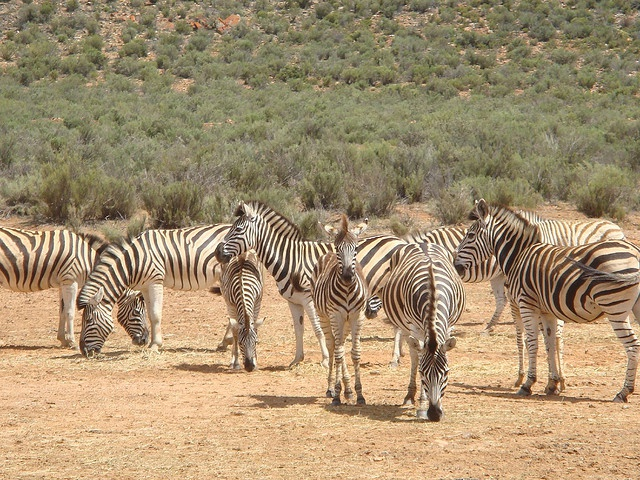Describe the objects in this image and their specific colors. I can see zebra in darkgreen, gray, tan, black, and maroon tones, zebra in darkgreen, beige, tan, and gray tones, zebra in darkgreen, gray, tan, beige, and maroon tones, zebra in darkgreen, gray, and tan tones, and zebra in darkgreen, tan, beige, and gray tones in this image. 